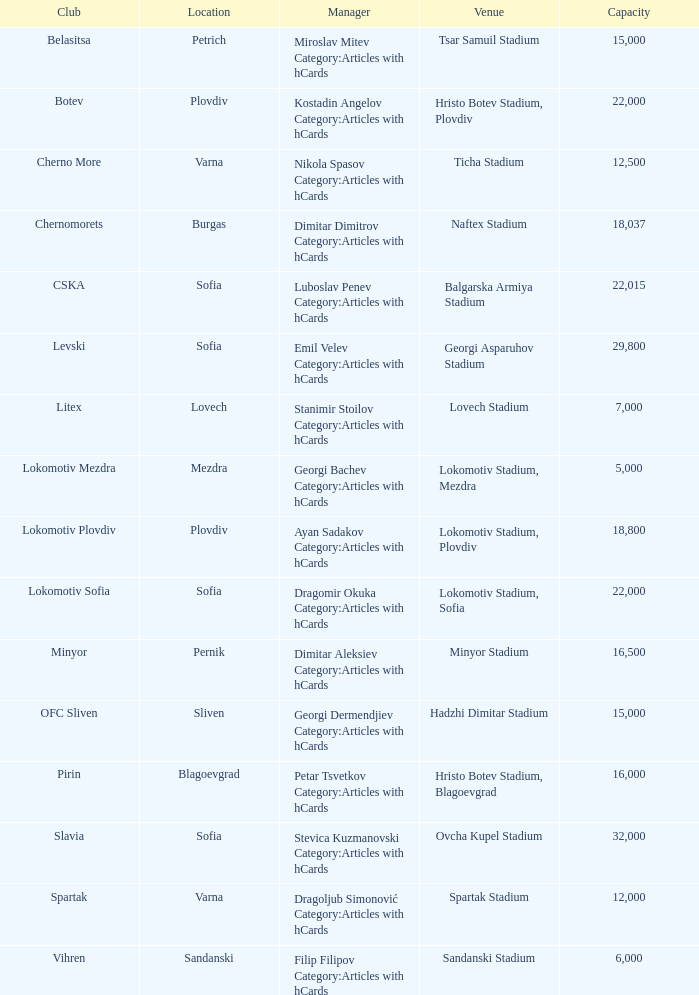What is the total number of capacity for the venue of the club, pirin? 1.0. 